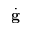Convert formula to latex. <formula><loc_0><loc_0><loc_500><loc_500>\dot { g }</formula> 